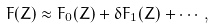Convert formula to latex. <formula><loc_0><loc_0><loc_500><loc_500>F ( Z ) \approx F _ { 0 } ( Z ) + \delta F _ { 1 } ( Z ) + \cdots ,</formula> 